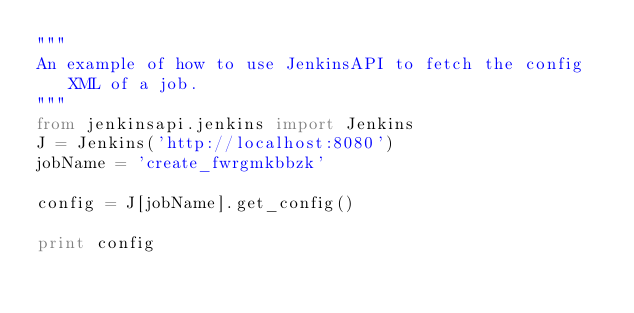<code> <loc_0><loc_0><loc_500><loc_500><_Python_>"""
An example of how to use JenkinsAPI to fetch the config XML of a job.
"""
from jenkinsapi.jenkins import Jenkins
J = Jenkins('http://localhost:8080')
jobName = 'create_fwrgmkbbzk'

config = J[jobName].get_config()

print config
</code> 